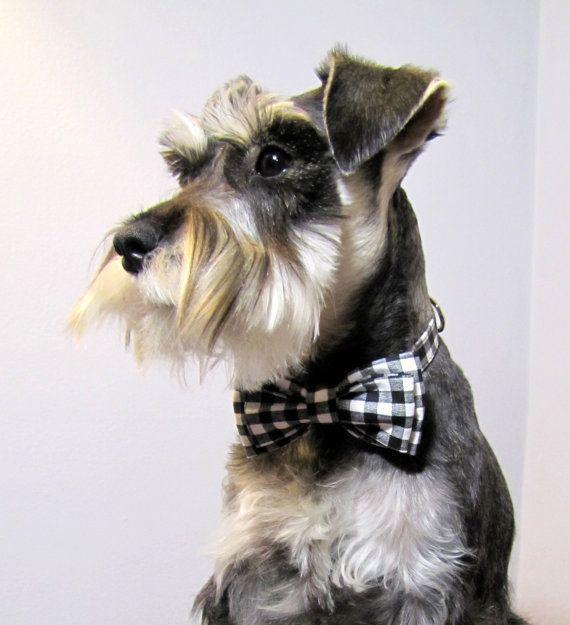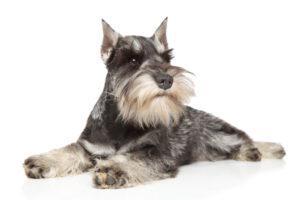The first image is the image on the left, the second image is the image on the right. For the images shown, is this caption "There are two dogs in each image." true? Answer yes or no. No. 